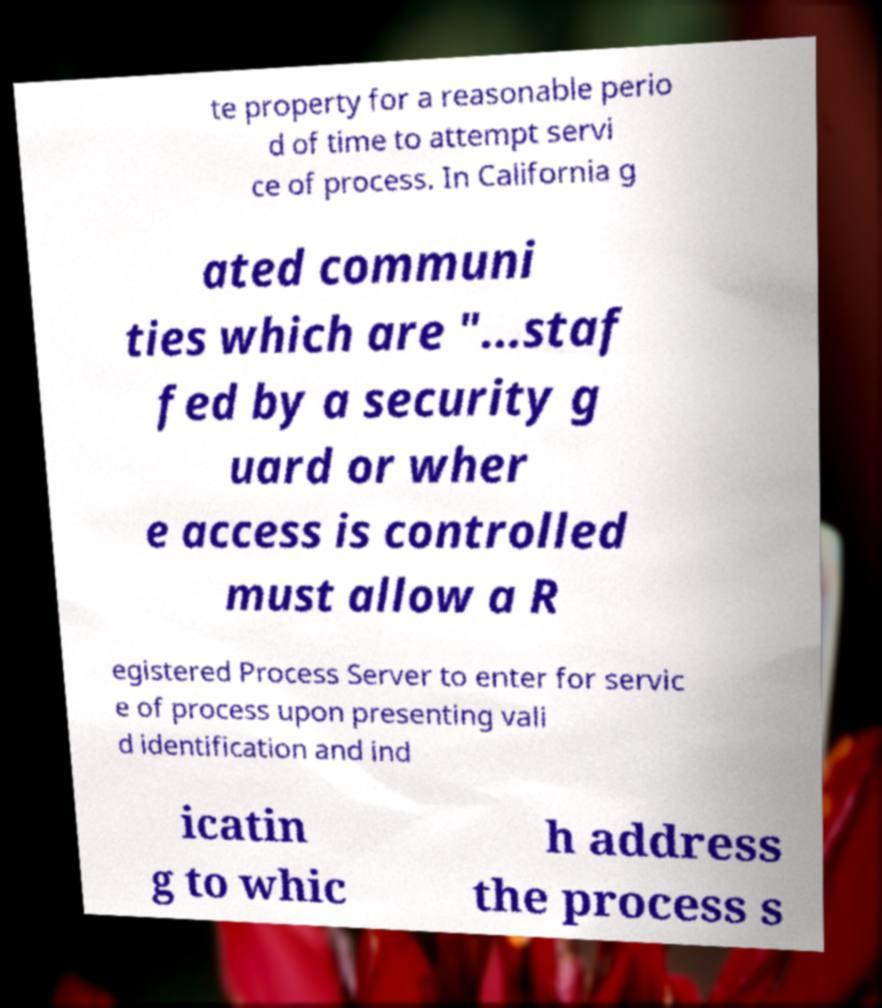There's text embedded in this image that I need extracted. Can you transcribe it verbatim? te property for a reasonable perio d of time to attempt servi ce of process. In California g ated communi ties which are "...staf fed by a security g uard or wher e access is controlled must allow a R egistered Process Server to enter for servic e of process upon presenting vali d identification and ind icatin g to whic h address the process s 